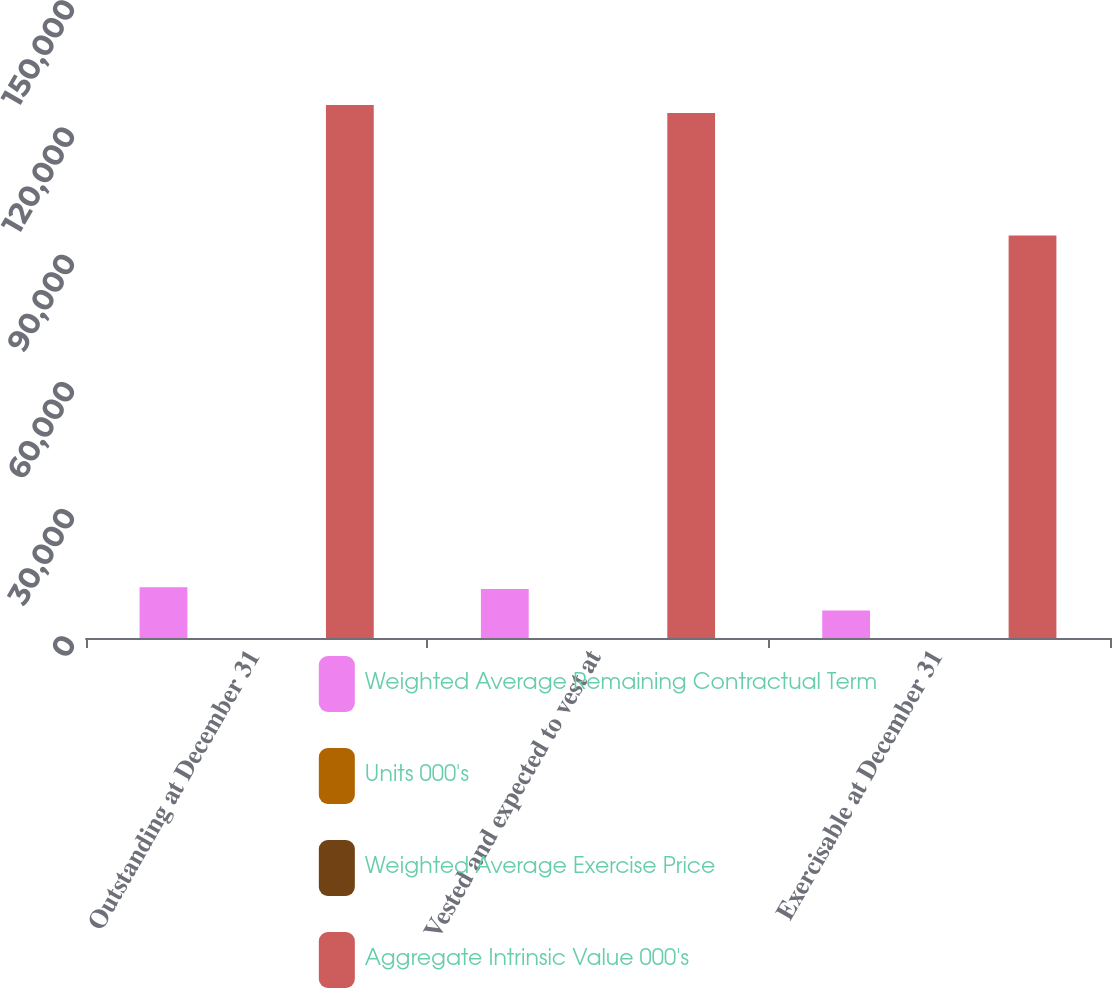<chart> <loc_0><loc_0><loc_500><loc_500><stacked_bar_chart><ecel><fcel>Outstanding at December 31<fcel>Vested and expected to vest at<fcel>Exercisable at December 31<nl><fcel>Weighted Average Remaining Contractual Term<fcel>11973<fcel>11570<fcel>6478<nl><fcel>Units 000's<fcel>18.33<fcel>18.12<fcel>14.16<nl><fcel>Weighted Average Exercise Price<fcel>4.27<fcel>4.2<fcel>2.9<nl><fcel>Aggregate Intrinsic Value 000's<fcel>125682<fcel>123841<fcel>94903<nl></chart> 